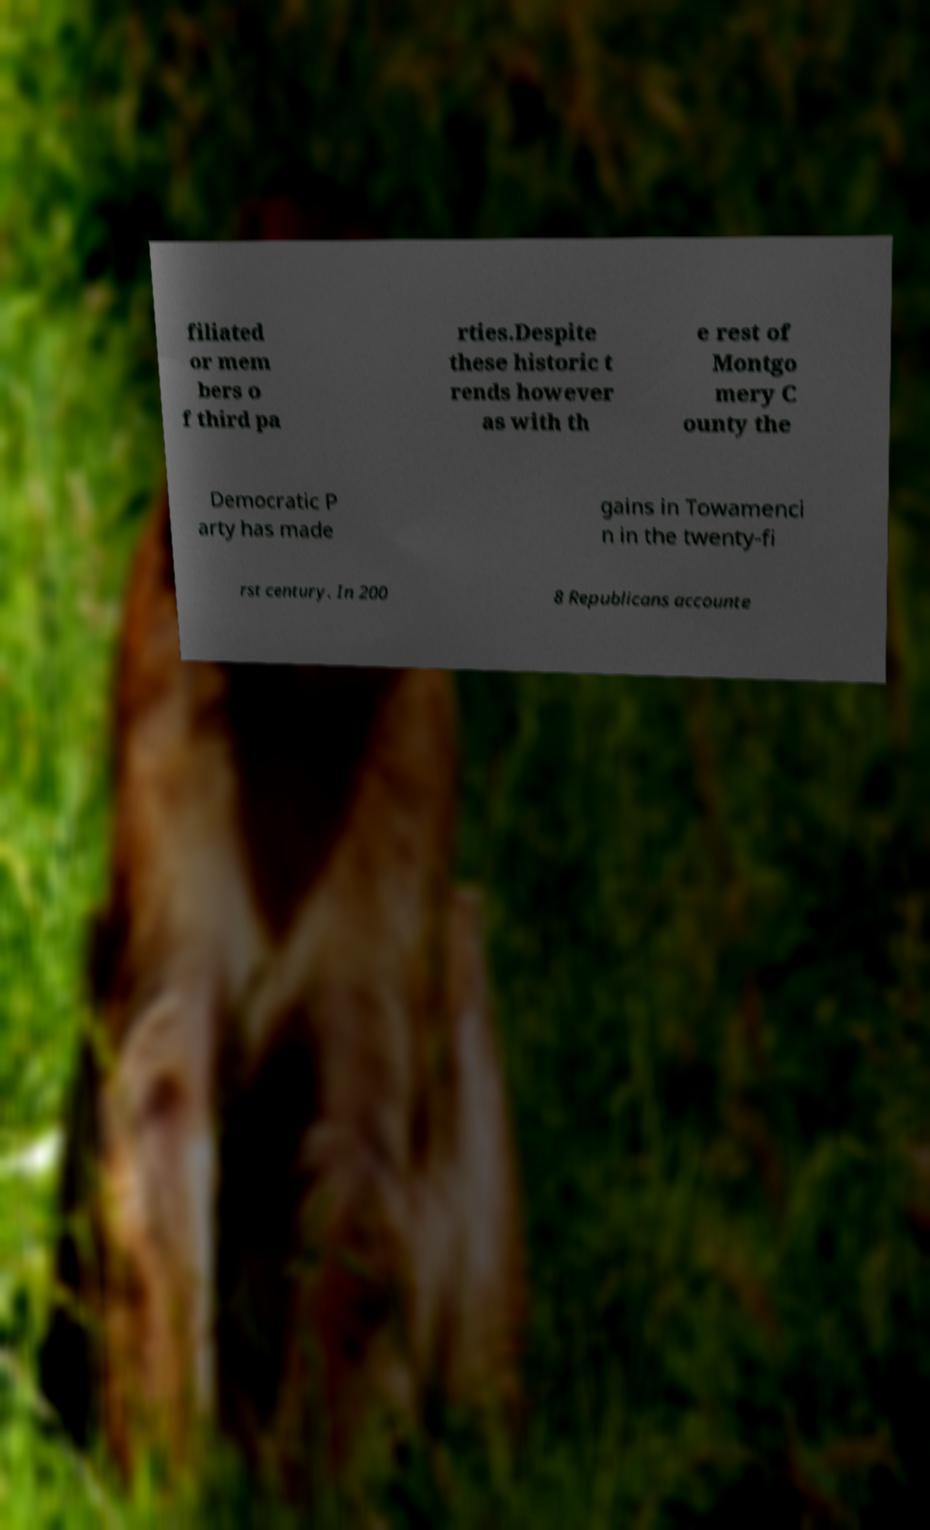Can you accurately transcribe the text from the provided image for me? filiated or mem bers o f third pa rties.Despite these historic t rends however as with th e rest of Montgo mery C ounty the Democratic P arty has made gains in Towamenci n in the twenty-fi rst century. In 200 8 Republicans accounte 